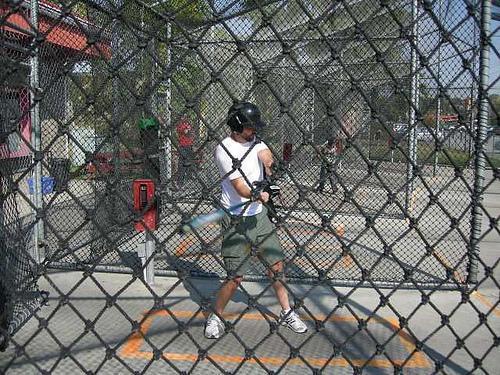How many people are there?
Give a very brief answer. 1. 